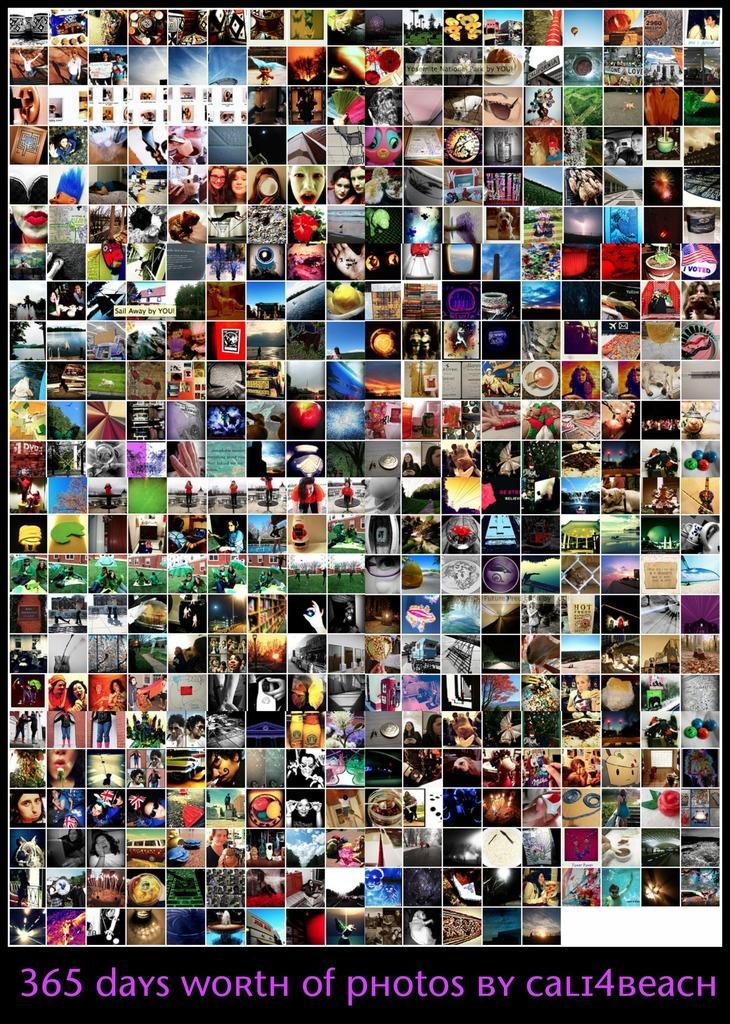Describe this image in one or two sentences. In this image I can see it is the photo collage, there are many photos in this. There is the text in purple color. 